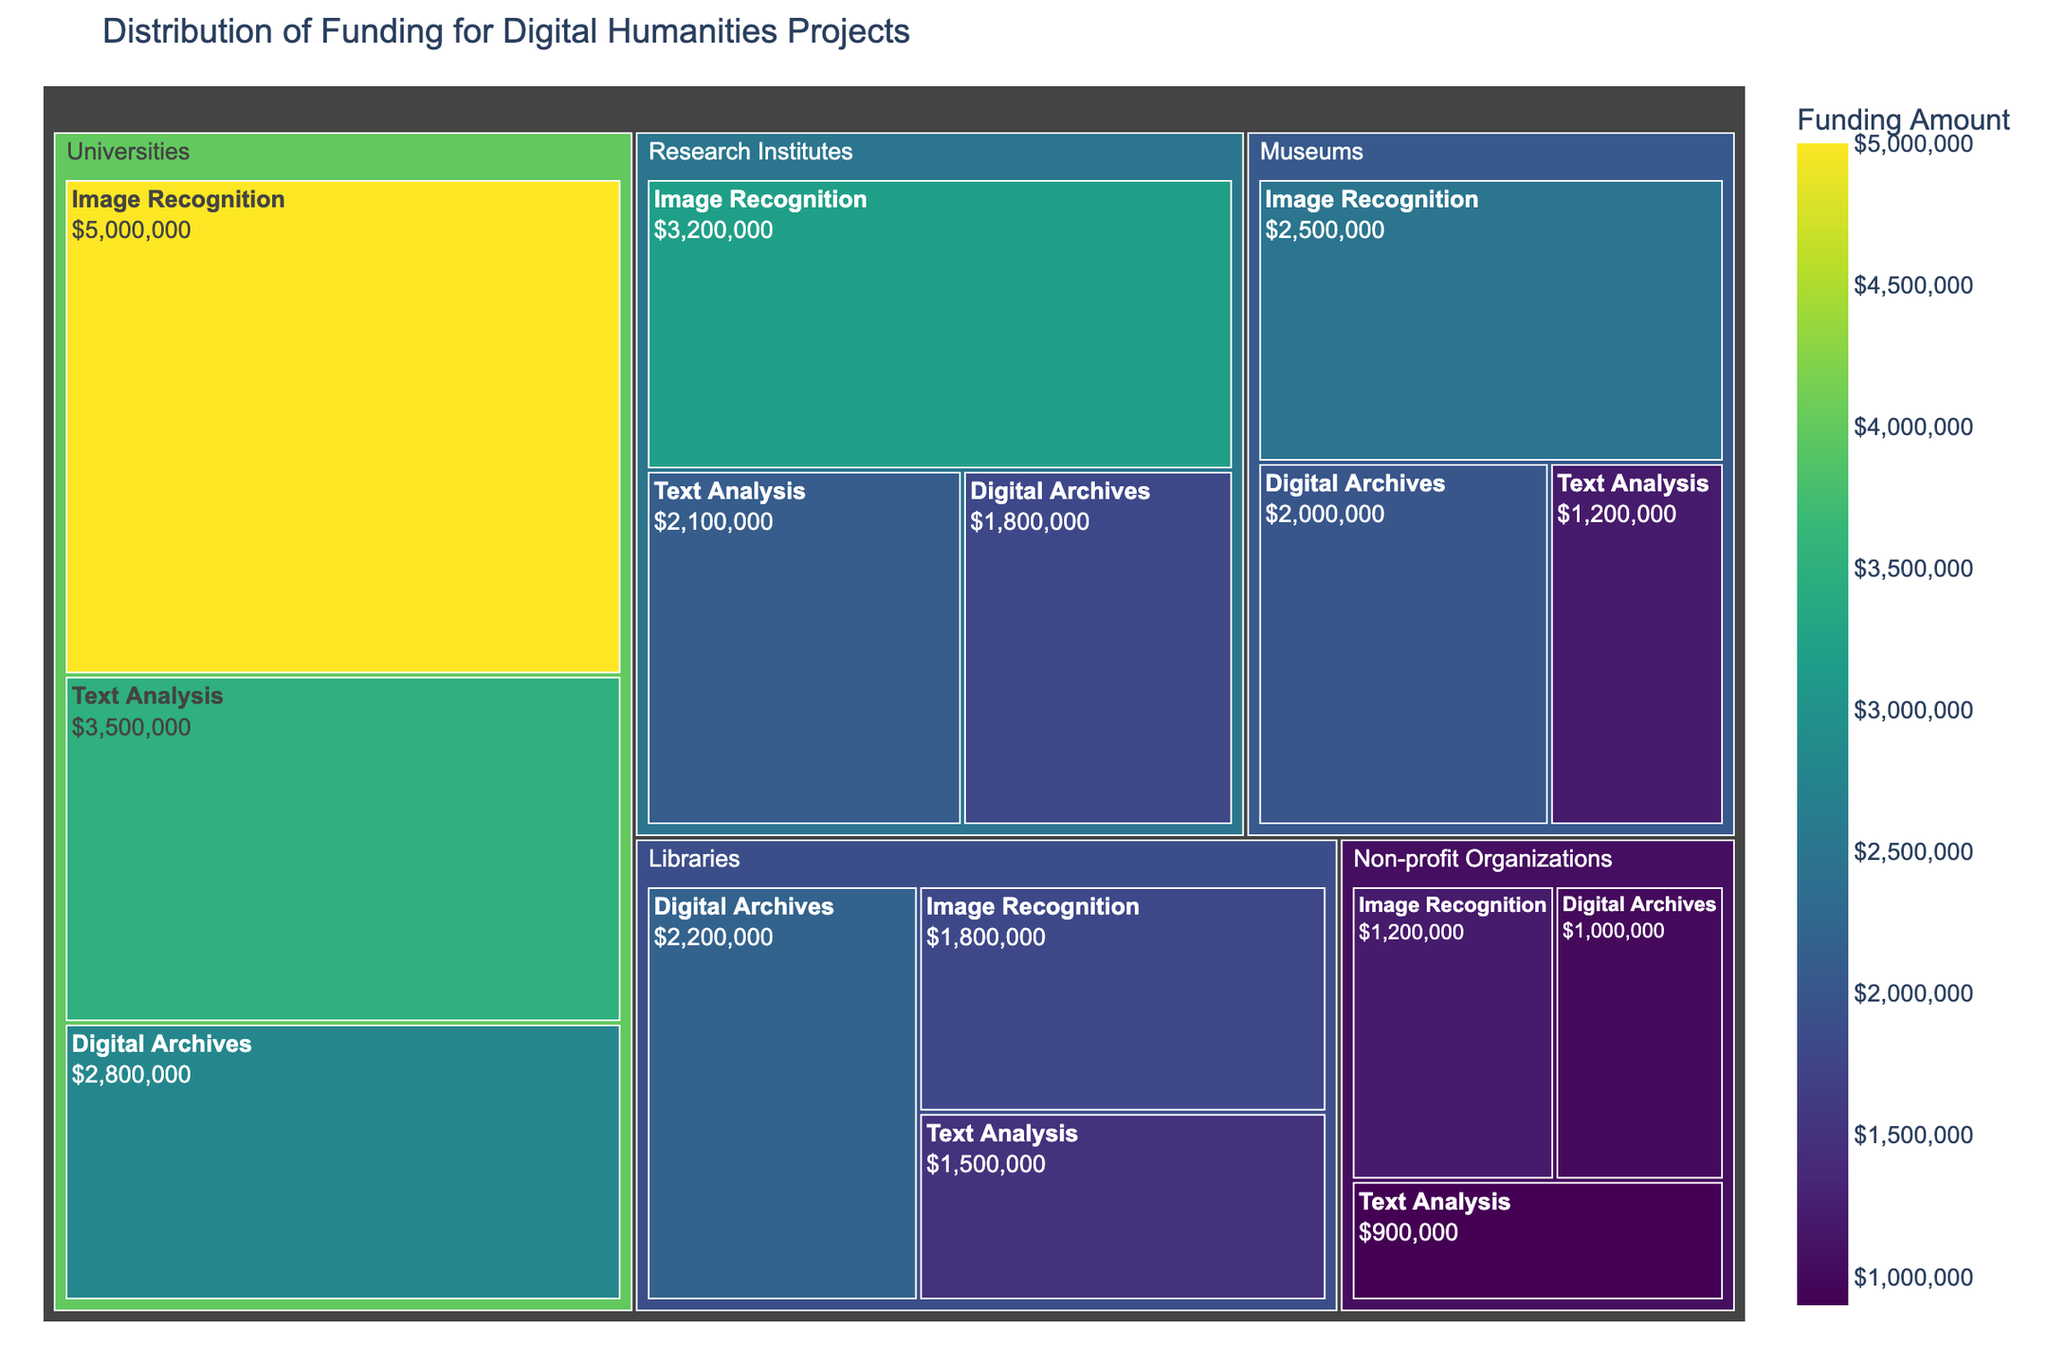what is the total funding amount provided to 'Universities' We need to sum up all the funding amounts for the 'Universities' category. This includes 5000000 for Image Recognition, 3500000 for Text Analysis, and 2800000 for Digital Archives. The total is 5000000 + 3500000 + 2800000 = 11300000
Answer: 11300000 which research focus has received the highest funding amount overall Review all the funding amounts and identify the highest value. The funding amounts are 5000000, 3500000, 2800000, 3200000, 2100000, 1800000, 2500000, 1200000, 2000000, 1800000, 1500000, 2200000, 1200000, 900000, 1000000. The highest amount is 5000000, which is for Image Recognition at Universities
Answer: Image Recognition compare the funding for 'Text Analysis' between 'Research Institutes' and 'Libraries' and identify which institution type received more funding for this research focus The funding for 'Text Analysis' in 'Research Institutes' is 2100000 and in 'Libraries' is 1500000. Comparing the two values, 2100000 is greater than 1500000
Answer: Research Institutes what is the combined funding amount for 'Libraries' in 'Digital Archives' and 'Text Analysis' research focuses Sum the funding amounts for 'Digital Archives' and 'Text Analysis' in 'Libraries'. This includes 2200000 for Digital Archives and 1500000 for Text Analysis. The total is 2200000 + 1500000 = 3700000
Answer: 3700000 how does the funding for 'Museums' in 'Image Recognition' compare to 'Non-profit Organizations' in the same research focus The funding for 'Museums' in 'Image Recognition' is 2500000, and the funding for Non-profit Organizations for the same research focus is 1200000. 2500000 is greater than 1200000
Answer: Museums what is the average funding amount across all institution types for 'Digital Archives' Sum the funding amounts for 'Digital Archives' across all institution types, then divide by the number of institution types. The amounts are 2800000 (Universities), 1800000 (Research Institutes), 2000000 (Museums), 2200000 (Libraries), 1000000 (Non-profit Organizations). The total is 2800000 + 1800000 + 2000000 + 2200000 + 1000000 = 9800000. The number of institution types is 5. The average is 9800000 / 5 = 1960000
Answer: 1960000 identify the institution type with the lowest total funding amount and provide the sum Calculate the total funding for each institution type and find the lowest. Summing the amounts for each type:
- Universities: 5000000 + 3500000 + 2800000 = 11300000
- Research Institutes: 3200000 + 2100000 + 1800000 = 7100000
- Museums: 2500000 + 1200000 + 2000000 = 5700000
- Libraries: 1800000 + 1500000 + 2200000 = 5500000
- Non-profit Organizations: 1200000 + 900000 + 1000000 = 3100000. The lowest total funding is 3100000 for Non-profit Organizations
Answer: Non-profit Organizations which research focus in 'Libraries' has the highest funding amount and what is the value Review the funding amounts for each research focus in 'Libraries': Image Recognition (1800000), Text Analysis (1500000), Digital Archives (2200000). The highest funding amount is for Digital Archives with a value of 2200000
Answer: Digital Archives what is the funding difference between 'Universities' and 'Research Institutes' in 'Digital Archives' The funding for 'Digital Archives' in 'Universities' is 2800000, and in 'Research Institutes' it is 1800000. The difference is 2800000 - 1800000 = 1000000
Answer: 1000000 considering all institution types, how much more funding does 'Image Recognition' receive compared to 'Text Analysis' Sum the funding amounts for 'Image Recognition' and 'Text Analysis' across all institution types, and then find the difference. 
- Image Recognition: 5000000 (Universities) + 3200000 (Research Institutes) + 2500000 (Museums) + 1800000 (Libraries) + 1200000 (Non-profit Organizations) = 13700000
- Text Analysis: 3500000 (Universities) + 2100000 (Research Institutes) + 1200000 (Museums) + 1500000 (Libraries) + 900000 (Non-profit Organizations) = 9200000
- The difference is 13700000 - 9200000 = 4500000
Answer: 4500000 